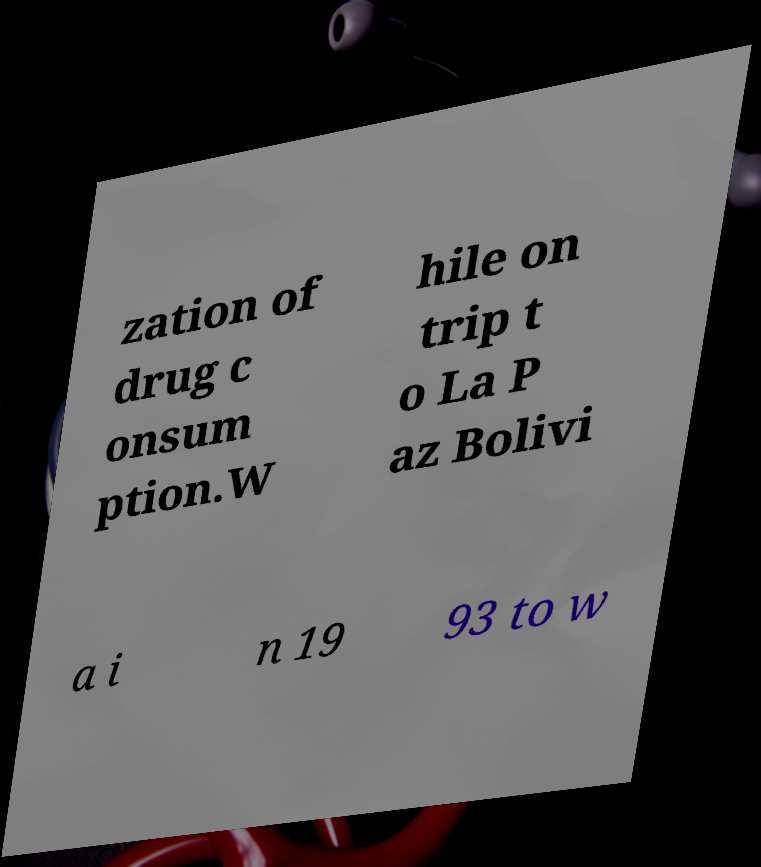Can you accurately transcribe the text from the provided image for me? zation of drug c onsum ption.W hile on trip t o La P az Bolivi a i n 19 93 to w 